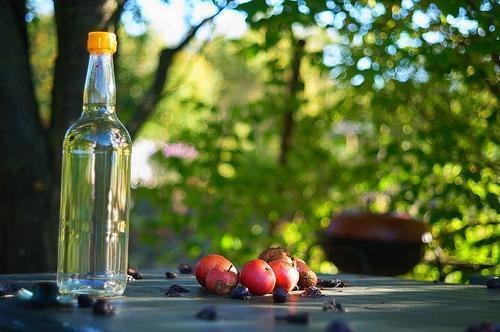How many apples are there?
Give a very brief answer. 4. 